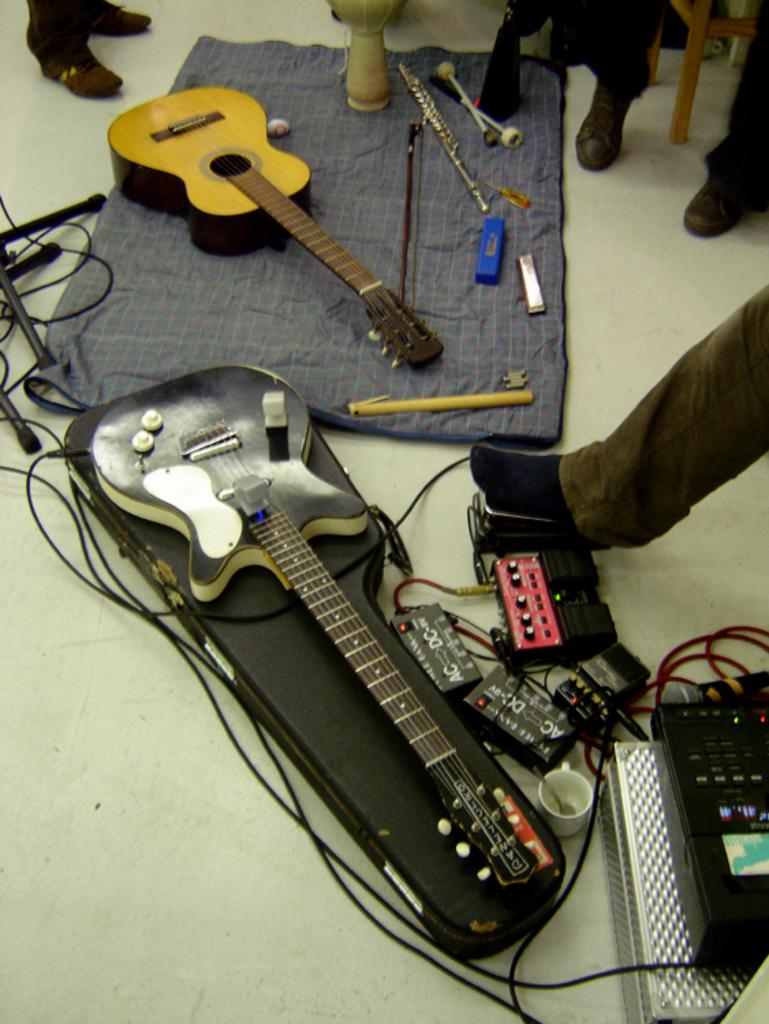What musical instruments are present in the image? There are two guitars in the image. Where are the guitars located? The guitars are on the floor. What else can be found on the floor in the image? There are other objects on the floor in the image. How does the queen interact with the crowd in the image? There is no queen or crowd present in the image; it only features two guitars on the floor and other unspecified objects. 